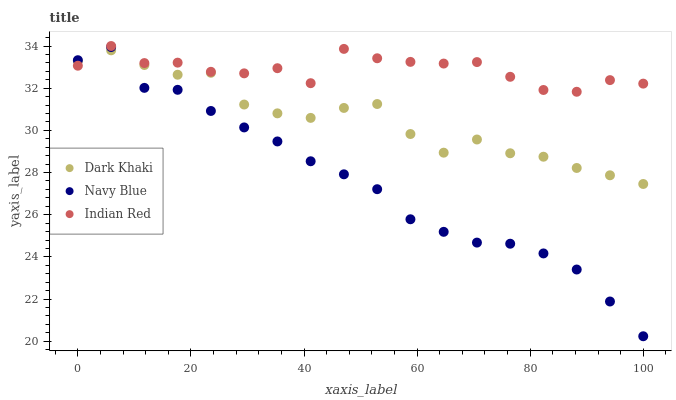Does Navy Blue have the minimum area under the curve?
Answer yes or no. Yes. Does Indian Red have the maximum area under the curve?
Answer yes or no. Yes. Does Indian Red have the minimum area under the curve?
Answer yes or no. No. Does Navy Blue have the maximum area under the curve?
Answer yes or no. No. Is Navy Blue the smoothest?
Answer yes or no. Yes. Is Indian Red the roughest?
Answer yes or no. Yes. Is Indian Red the smoothest?
Answer yes or no. No. Is Navy Blue the roughest?
Answer yes or no. No. Does Navy Blue have the lowest value?
Answer yes or no. Yes. Does Indian Red have the lowest value?
Answer yes or no. No. Does Indian Red have the highest value?
Answer yes or no. Yes. Does Navy Blue have the highest value?
Answer yes or no. No. Does Indian Red intersect Dark Khaki?
Answer yes or no. Yes. Is Indian Red less than Dark Khaki?
Answer yes or no. No. Is Indian Red greater than Dark Khaki?
Answer yes or no. No. 